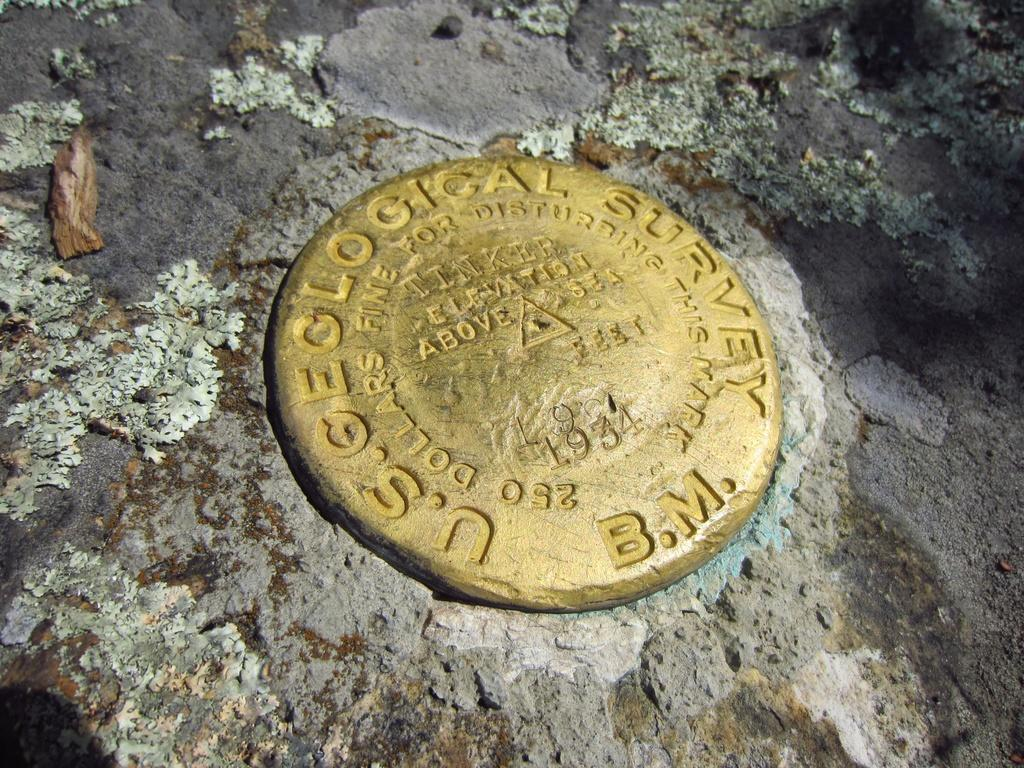<image>
Share a concise interpretation of the image provided. Yellow circle that says B.M. on it on the ground. 